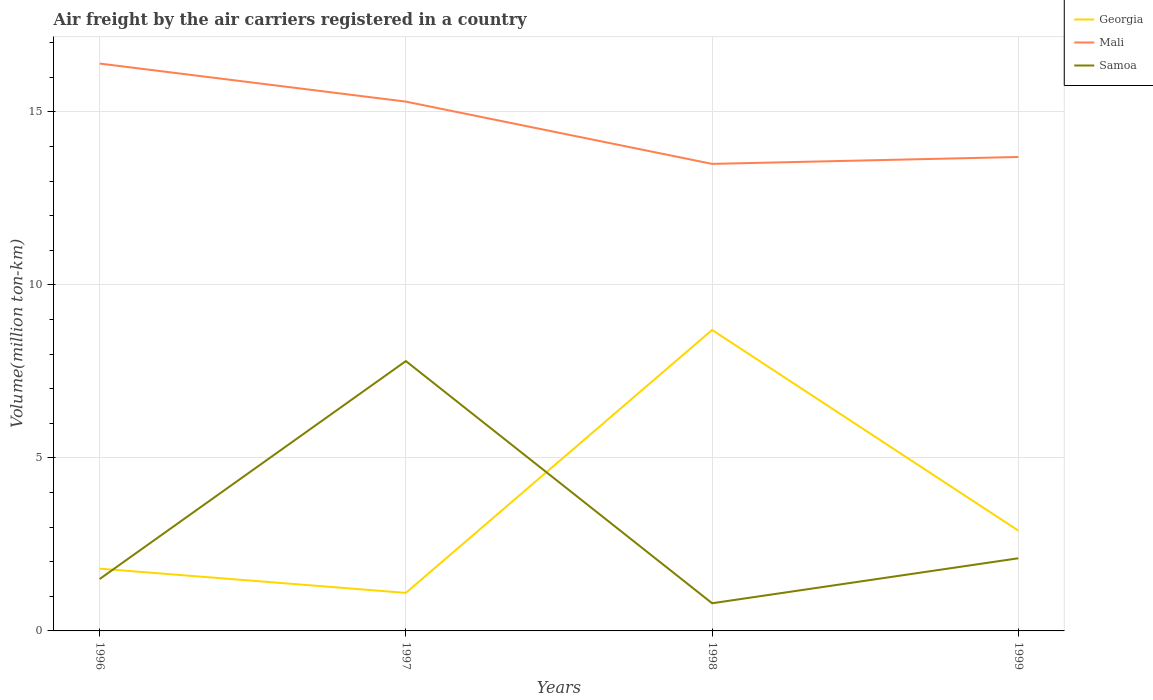Does the line corresponding to Samoa intersect with the line corresponding to Georgia?
Your answer should be compact. Yes. Is the number of lines equal to the number of legend labels?
Provide a short and direct response. Yes. Across all years, what is the maximum volume of the air carriers in Samoa?
Your answer should be very brief. 0.8. What is the total volume of the air carriers in Mali in the graph?
Your answer should be very brief. 2.7. What is the difference between the highest and the second highest volume of the air carriers in Samoa?
Offer a terse response. 7. How many years are there in the graph?
Provide a short and direct response. 4. Does the graph contain grids?
Your response must be concise. Yes. Where does the legend appear in the graph?
Your answer should be compact. Top right. How many legend labels are there?
Ensure brevity in your answer.  3. What is the title of the graph?
Your answer should be compact. Air freight by the air carriers registered in a country. What is the label or title of the X-axis?
Your answer should be compact. Years. What is the label or title of the Y-axis?
Offer a terse response. Volume(million ton-km). What is the Volume(million ton-km) of Georgia in 1996?
Keep it short and to the point. 1.8. What is the Volume(million ton-km) in Mali in 1996?
Your answer should be compact. 16.4. What is the Volume(million ton-km) of Georgia in 1997?
Provide a short and direct response. 1.1. What is the Volume(million ton-km) of Mali in 1997?
Offer a terse response. 15.3. What is the Volume(million ton-km) in Samoa in 1997?
Provide a short and direct response. 7.8. What is the Volume(million ton-km) of Georgia in 1998?
Provide a succinct answer. 8.7. What is the Volume(million ton-km) of Mali in 1998?
Provide a succinct answer. 13.5. What is the Volume(million ton-km) in Samoa in 1998?
Provide a short and direct response. 0.8. What is the Volume(million ton-km) of Georgia in 1999?
Offer a very short reply. 2.9. What is the Volume(million ton-km) in Mali in 1999?
Provide a short and direct response. 13.7. What is the Volume(million ton-km) of Samoa in 1999?
Your answer should be compact. 2.1. Across all years, what is the maximum Volume(million ton-km) of Georgia?
Your answer should be very brief. 8.7. Across all years, what is the maximum Volume(million ton-km) in Mali?
Provide a short and direct response. 16.4. Across all years, what is the maximum Volume(million ton-km) in Samoa?
Offer a very short reply. 7.8. Across all years, what is the minimum Volume(million ton-km) of Georgia?
Provide a succinct answer. 1.1. Across all years, what is the minimum Volume(million ton-km) of Mali?
Make the answer very short. 13.5. Across all years, what is the minimum Volume(million ton-km) of Samoa?
Your response must be concise. 0.8. What is the total Volume(million ton-km) in Georgia in the graph?
Keep it short and to the point. 14.5. What is the total Volume(million ton-km) in Mali in the graph?
Your answer should be very brief. 58.9. What is the total Volume(million ton-km) in Samoa in the graph?
Provide a short and direct response. 12.2. What is the difference between the Volume(million ton-km) of Georgia in 1996 and that in 1997?
Your answer should be very brief. 0.7. What is the difference between the Volume(million ton-km) in Mali in 1996 and that in 1997?
Your answer should be compact. 1.1. What is the difference between the Volume(million ton-km) in Georgia in 1996 and that in 1999?
Your response must be concise. -1.1. What is the difference between the Volume(million ton-km) of Mali in 1996 and that in 1999?
Your response must be concise. 2.7. What is the difference between the Volume(million ton-km) in Samoa in 1996 and that in 1999?
Provide a short and direct response. -0.6. What is the difference between the Volume(million ton-km) of Georgia in 1997 and that in 1998?
Keep it short and to the point. -7.6. What is the difference between the Volume(million ton-km) in Mali in 1997 and that in 1998?
Provide a short and direct response. 1.8. What is the difference between the Volume(million ton-km) in Georgia in 1996 and the Volume(million ton-km) in Samoa in 1997?
Your answer should be very brief. -6. What is the difference between the Volume(million ton-km) in Georgia in 1996 and the Volume(million ton-km) in Mali in 1998?
Offer a very short reply. -11.7. What is the difference between the Volume(million ton-km) of Georgia in 1996 and the Volume(million ton-km) of Samoa in 1998?
Your answer should be very brief. 1. What is the difference between the Volume(million ton-km) in Mali in 1996 and the Volume(million ton-km) in Samoa in 1998?
Ensure brevity in your answer.  15.6. What is the difference between the Volume(million ton-km) in Georgia in 1996 and the Volume(million ton-km) in Samoa in 1999?
Ensure brevity in your answer.  -0.3. What is the difference between the Volume(million ton-km) in Mali in 1996 and the Volume(million ton-km) in Samoa in 1999?
Keep it short and to the point. 14.3. What is the difference between the Volume(million ton-km) of Georgia in 1997 and the Volume(million ton-km) of Samoa in 1998?
Your answer should be very brief. 0.3. What is the difference between the Volume(million ton-km) of Georgia in 1997 and the Volume(million ton-km) of Mali in 1999?
Offer a terse response. -12.6. What is the difference between the Volume(million ton-km) in Georgia in 1997 and the Volume(million ton-km) in Samoa in 1999?
Offer a terse response. -1. What is the difference between the Volume(million ton-km) in Mali in 1997 and the Volume(million ton-km) in Samoa in 1999?
Provide a succinct answer. 13.2. What is the difference between the Volume(million ton-km) of Georgia in 1998 and the Volume(million ton-km) of Mali in 1999?
Your answer should be compact. -5. What is the average Volume(million ton-km) of Georgia per year?
Make the answer very short. 3.62. What is the average Volume(million ton-km) of Mali per year?
Provide a short and direct response. 14.72. What is the average Volume(million ton-km) in Samoa per year?
Provide a succinct answer. 3.05. In the year 1996, what is the difference between the Volume(million ton-km) in Georgia and Volume(million ton-km) in Mali?
Your answer should be very brief. -14.6. In the year 1997, what is the difference between the Volume(million ton-km) in Mali and Volume(million ton-km) in Samoa?
Give a very brief answer. 7.5. In the year 1998, what is the difference between the Volume(million ton-km) in Georgia and Volume(million ton-km) in Samoa?
Your response must be concise. 7.9. In the year 1998, what is the difference between the Volume(million ton-km) of Mali and Volume(million ton-km) of Samoa?
Ensure brevity in your answer.  12.7. In the year 1999, what is the difference between the Volume(million ton-km) in Georgia and Volume(million ton-km) in Mali?
Offer a very short reply. -10.8. In the year 1999, what is the difference between the Volume(million ton-km) in Georgia and Volume(million ton-km) in Samoa?
Keep it short and to the point. 0.8. What is the ratio of the Volume(million ton-km) in Georgia in 1996 to that in 1997?
Offer a very short reply. 1.64. What is the ratio of the Volume(million ton-km) in Mali in 1996 to that in 1997?
Provide a succinct answer. 1.07. What is the ratio of the Volume(million ton-km) in Samoa in 1996 to that in 1997?
Your answer should be very brief. 0.19. What is the ratio of the Volume(million ton-km) in Georgia in 1996 to that in 1998?
Your answer should be compact. 0.21. What is the ratio of the Volume(million ton-km) in Mali in 1996 to that in 1998?
Ensure brevity in your answer.  1.21. What is the ratio of the Volume(million ton-km) of Samoa in 1996 to that in 1998?
Offer a very short reply. 1.88. What is the ratio of the Volume(million ton-km) in Georgia in 1996 to that in 1999?
Offer a very short reply. 0.62. What is the ratio of the Volume(million ton-km) of Mali in 1996 to that in 1999?
Offer a terse response. 1.2. What is the ratio of the Volume(million ton-km) in Georgia in 1997 to that in 1998?
Offer a terse response. 0.13. What is the ratio of the Volume(million ton-km) in Mali in 1997 to that in 1998?
Give a very brief answer. 1.13. What is the ratio of the Volume(million ton-km) of Samoa in 1997 to that in 1998?
Keep it short and to the point. 9.75. What is the ratio of the Volume(million ton-km) of Georgia in 1997 to that in 1999?
Your response must be concise. 0.38. What is the ratio of the Volume(million ton-km) of Mali in 1997 to that in 1999?
Your answer should be very brief. 1.12. What is the ratio of the Volume(million ton-km) of Samoa in 1997 to that in 1999?
Your answer should be compact. 3.71. What is the ratio of the Volume(million ton-km) of Mali in 1998 to that in 1999?
Provide a succinct answer. 0.99. What is the ratio of the Volume(million ton-km) of Samoa in 1998 to that in 1999?
Your answer should be very brief. 0.38. What is the difference between the highest and the second highest Volume(million ton-km) in Georgia?
Provide a short and direct response. 5.8. What is the difference between the highest and the second highest Volume(million ton-km) of Samoa?
Make the answer very short. 5.7. What is the difference between the highest and the lowest Volume(million ton-km) of Mali?
Offer a very short reply. 2.9. What is the difference between the highest and the lowest Volume(million ton-km) of Samoa?
Make the answer very short. 7. 